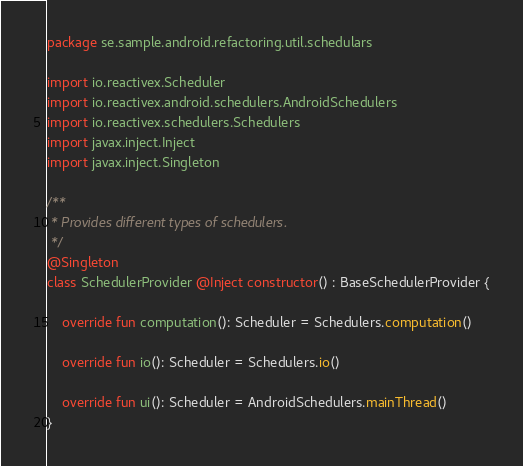Convert code to text. <code><loc_0><loc_0><loc_500><loc_500><_Kotlin_>package se.sample.android.refactoring.util.schedulars

import io.reactivex.Scheduler
import io.reactivex.android.schedulers.AndroidSchedulers
import io.reactivex.schedulers.Schedulers
import javax.inject.Inject
import javax.inject.Singleton

/**
 * Provides different types of schedulers.
 */
@Singleton
class SchedulerProvider @Inject constructor() : BaseSchedulerProvider {

    override fun computation(): Scheduler = Schedulers.computation()

    override fun io(): Scheduler = Schedulers.io()

    override fun ui(): Scheduler = AndroidSchedulers.mainThread()
}</code> 